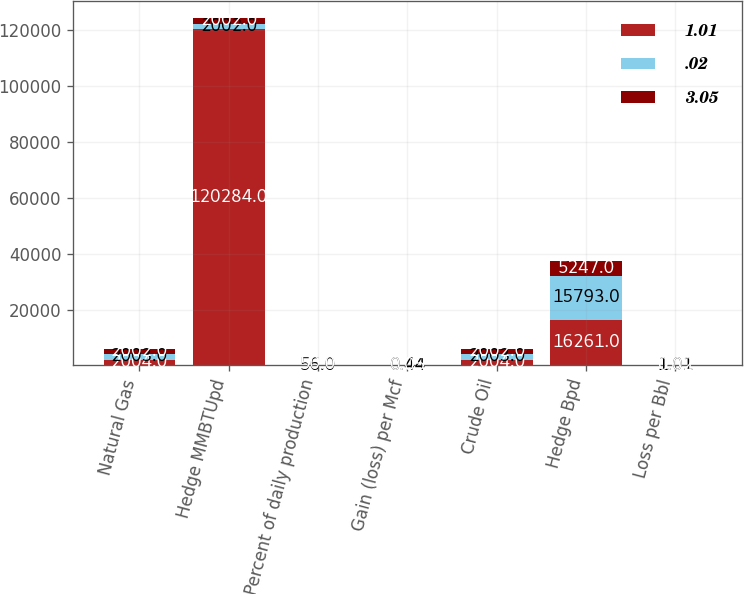Convert chart. <chart><loc_0><loc_0><loc_500><loc_500><stacked_bar_chart><ecel><fcel>Natural Gas<fcel>Hedge MMBTUpd<fcel>Percent of daily production<fcel>Gain (loss) per Mcf<fcel>Crude Oil<fcel>Hedge Bpd<fcel>Loss per Bbl<nl><fcel>1.01<fcel>2004<fcel>120284<fcel>33<fcel>0.08<fcel>2004<fcel>16261<fcel>3.05<nl><fcel>0.02<fcel>2003<fcel>2002<fcel>56<fcel>0.44<fcel>2003<fcel>15793<fcel>1.01<nl><fcel>3.05<fcel>2002<fcel>2002<fcel>50<fcel>0.05<fcel>2002<fcel>5247<fcel>0.02<nl></chart> 